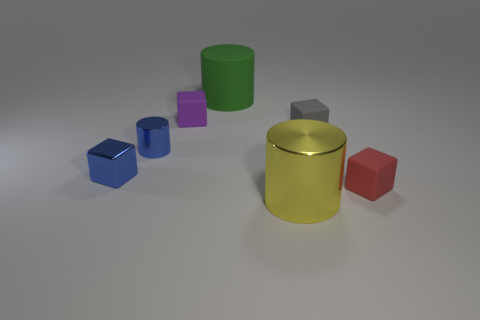Add 2 tiny rubber blocks. How many objects exist? 9 Subtract all blocks. How many objects are left? 3 Add 6 tiny metallic cylinders. How many tiny metallic cylinders exist? 7 Subtract 1 gray blocks. How many objects are left? 6 Subtract all small purple rubber cubes. Subtract all tiny gray blocks. How many objects are left? 5 Add 1 blue blocks. How many blue blocks are left? 2 